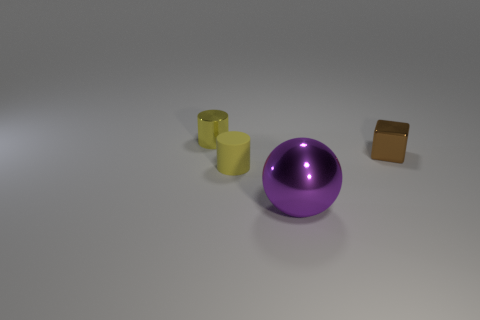Add 1 large purple balls. How many objects exist? 5 Subtract all spheres. How many objects are left? 3 Add 1 small yellow metal objects. How many small yellow metal objects are left? 2 Add 1 tiny matte cylinders. How many tiny matte cylinders exist? 2 Subtract 0 gray balls. How many objects are left? 4 Subtract all metal balls. Subtract all large green cylinders. How many objects are left? 3 